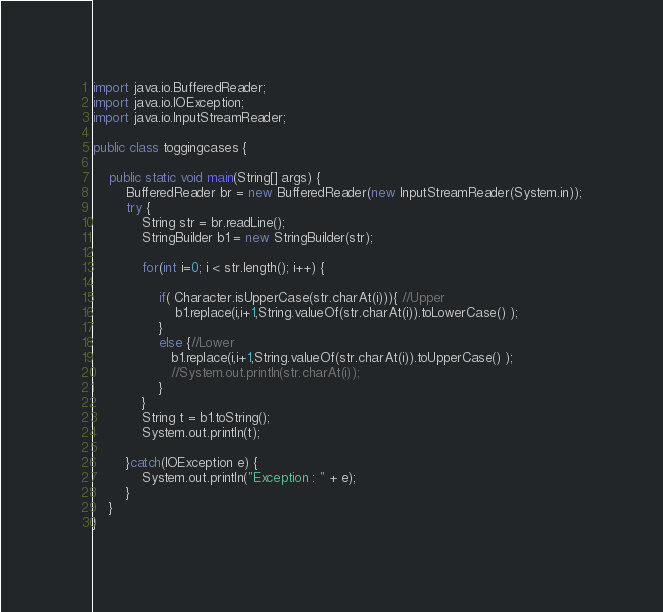Convert code to text. <code><loc_0><loc_0><loc_500><loc_500><_Java_>import java.io.BufferedReader;
import java.io.IOException;
import java.io.InputStreamReader;

public class toggingcases {

	public static void main(String[] args) {
		BufferedReader br = new BufferedReader(new InputStreamReader(System.in));
		try {
			String str = br.readLine();
			StringBuilder b1 = new StringBuilder(str);

			for(int i=0; i < str.length(); i++) {

				if( Character.isUpperCase(str.charAt(i))){ //Upper
				    b1.replace(i,i+1,String.valueOf(str.charAt(i)).toLowerCase() );
				}
				else {//Lower
				   b1.replace(i,i+1,String.valueOf(str.charAt(i)).toUpperCase() );
				   //System.out.println(str.charAt(i));
				}
			}
			String t = b1.toString();
			System.out.println(t);

		}catch(IOException e) {
			System.out.println("Exception : " + e);
		}
	}
}
</code> 